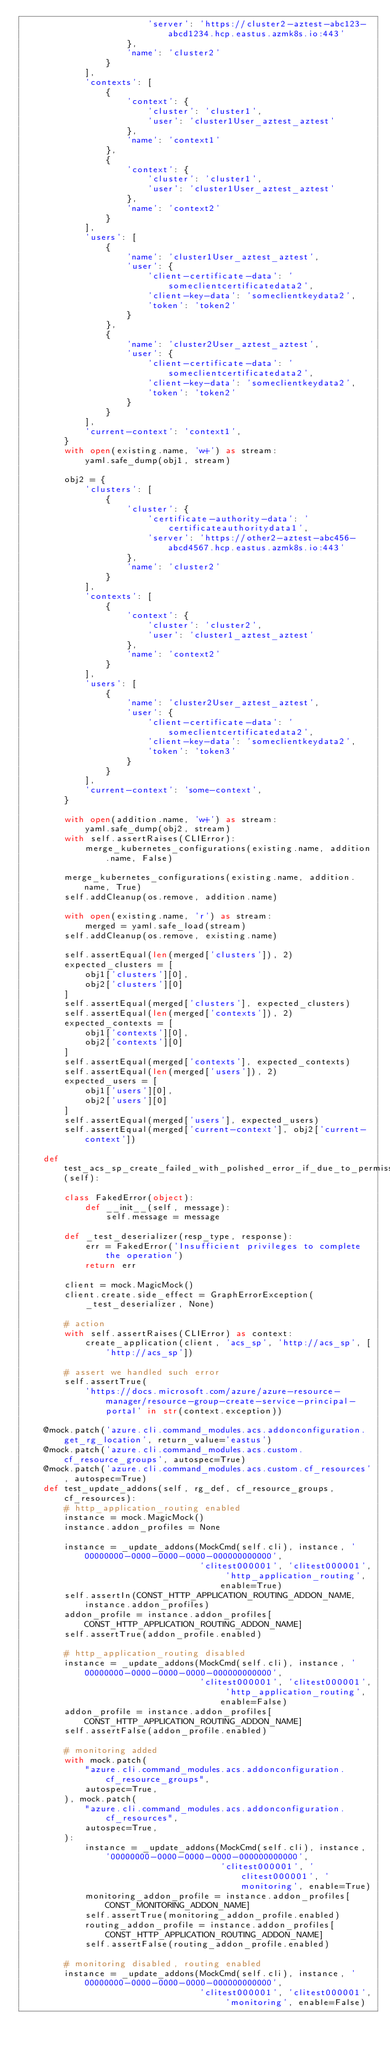Convert code to text. <code><loc_0><loc_0><loc_500><loc_500><_Python_>                        'server': 'https://cluster2-aztest-abc123-abcd1234.hcp.eastus.azmk8s.io:443'
                    },
                    'name': 'cluster2'
                }
            ],
            'contexts': [
                {
                    'context': {
                        'cluster': 'cluster1',
                        'user': 'cluster1User_aztest_aztest'
                    },
                    'name': 'context1'
                },
                {
                    'context': {
                        'cluster': 'cluster1',
                        'user': 'cluster1User_aztest_aztest'
                    },
                    'name': 'context2'
                }
            ],
            'users': [
                {
                    'name': 'cluster1User_aztest_aztest',
                    'user': {
                        'client-certificate-data': 'someclientcertificatedata2',
                        'client-key-data': 'someclientkeydata2',
                        'token': 'token2'
                    }
                },
                {
                    'name': 'cluster2User_aztest_aztest',
                    'user': {
                        'client-certificate-data': 'someclientcertificatedata2',
                        'client-key-data': 'someclientkeydata2',
                        'token': 'token2'
                    }
                }
            ],
            'current-context': 'context1',
        }
        with open(existing.name, 'w+') as stream:
            yaml.safe_dump(obj1, stream)

        obj2 = {
            'clusters': [
                {
                    'cluster': {
                        'certificate-authority-data': 'certificateauthoritydata1',
                        'server': 'https://other2-aztest-abc456-abcd4567.hcp.eastus.azmk8s.io:443'
                    },
                    'name': 'cluster2'
                }
            ],
            'contexts': [
                {
                    'context': {
                        'cluster': 'cluster2',
                        'user': 'cluster1_aztest_aztest'
                    },
                    'name': 'context2'
                }
            ],
            'users': [
                {
                    'name': 'cluster2User_aztest_aztest',
                    'user': {
                        'client-certificate-data': 'someclientcertificatedata2',
                        'client-key-data': 'someclientkeydata2',
                        'token': 'token3'
                    }
                }
            ],
            'current-context': 'some-context',
        }

        with open(addition.name, 'w+') as stream:
            yaml.safe_dump(obj2, stream)
        with self.assertRaises(CLIError):
            merge_kubernetes_configurations(existing.name, addition.name, False)

        merge_kubernetes_configurations(existing.name, addition.name, True)
        self.addCleanup(os.remove, addition.name)

        with open(existing.name, 'r') as stream:
            merged = yaml.safe_load(stream)
        self.addCleanup(os.remove, existing.name)

        self.assertEqual(len(merged['clusters']), 2)
        expected_clusters = [
            obj1['clusters'][0],
            obj2['clusters'][0]
        ]
        self.assertEqual(merged['clusters'], expected_clusters)
        self.assertEqual(len(merged['contexts']), 2)
        expected_contexts = [
            obj1['contexts'][0],
            obj2['contexts'][0]
        ]
        self.assertEqual(merged['contexts'], expected_contexts)
        self.assertEqual(len(merged['users']), 2)
        expected_users = [
            obj1['users'][0],
            obj2['users'][0]
        ]
        self.assertEqual(merged['users'], expected_users)
        self.assertEqual(merged['current-context'], obj2['current-context'])

    def test_acs_sp_create_failed_with_polished_error_if_due_to_permission(self):

        class FakedError(object):
            def __init__(self, message):
                self.message = message

        def _test_deserializer(resp_type, response):
            err = FakedError('Insufficient privileges to complete the operation')
            return err

        client = mock.MagicMock()
        client.create.side_effect = GraphErrorException(_test_deserializer, None)

        # action
        with self.assertRaises(CLIError) as context:
            create_application(client, 'acs_sp', 'http://acs_sp', ['http://acs_sp'])

        # assert we handled such error
        self.assertTrue(
            'https://docs.microsoft.com/azure/azure-resource-manager/resource-group-create-service-principal-portal' in str(context.exception))

    @mock.patch('azure.cli.command_modules.acs.addonconfiguration.get_rg_location', return_value='eastus')
    @mock.patch('azure.cli.command_modules.acs.custom.cf_resource_groups', autospec=True)
    @mock.patch('azure.cli.command_modules.acs.custom.cf_resources', autospec=True)
    def test_update_addons(self, rg_def, cf_resource_groups, cf_resources):
        # http_application_routing enabled
        instance = mock.MagicMock()
        instance.addon_profiles = None
        
        instance = _update_addons(MockCmd(self.cli), instance, '00000000-0000-0000-0000-000000000000',
                                  'clitest000001', 'clitest000001', 'http_application_routing', enable=True)
        self.assertIn(CONST_HTTP_APPLICATION_ROUTING_ADDON_NAME, instance.addon_profiles)
        addon_profile = instance.addon_profiles[CONST_HTTP_APPLICATION_ROUTING_ADDON_NAME]
        self.assertTrue(addon_profile.enabled)

        # http_application_routing disabled
        instance = _update_addons(MockCmd(self.cli), instance, '00000000-0000-0000-0000-000000000000',
                                  'clitest000001', 'clitest000001', 'http_application_routing', enable=False)
        addon_profile = instance.addon_profiles[CONST_HTTP_APPLICATION_ROUTING_ADDON_NAME]
        self.assertFalse(addon_profile.enabled)

        # monitoring added
        with mock.patch(
            "azure.cli.command_modules.acs.addonconfiguration.cf_resource_groups",
            autospec=True,
        ), mock.patch(
            "azure.cli.command_modules.acs.addonconfiguration.cf_resources",
            autospec=True,
        ):
            instance = _update_addons(MockCmd(self.cli), instance, '00000000-0000-0000-0000-000000000000',
                                      'clitest000001', 'clitest000001', 'monitoring', enable=True)
            monitoring_addon_profile = instance.addon_profiles[CONST_MONITORING_ADDON_NAME]
            self.assertTrue(monitoring_addon_profile.enabled)
            routing_addon_profile = instance.addon_profiles[CONST_HTTP_APPLICATION_ROUTING_ADDON_NAME]
            self.assertFalse(routing_addon_profile.enabled)

        # monitoring disabled, routing enabled
        instance = _update_addons(MockCmd(self.cli), instance, '00000000-0000-0000-0000-000000000000',
                                  'clitest000001', 'clitest000001', 'monitoring', enable=False)</code> 